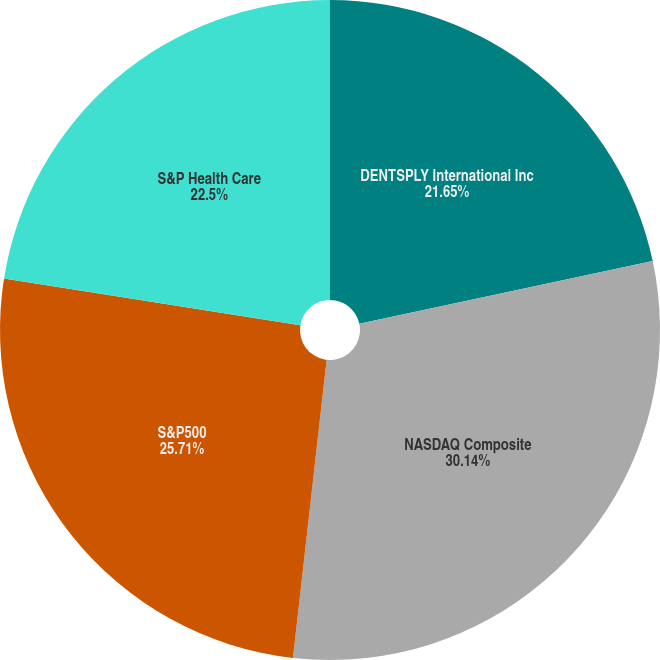<chart> <loc_0><loc_0><loc_500><loc_500><pie_chart><fcel>DENTSPLY International Inc<fcel>NASDAQ Composite<fcel>S&P500<fcel>S&P Health Care<nl><fcel>21.65%<fcel>30.14%<fcel>25.71%<fcel>22.5%<nl></chart> 